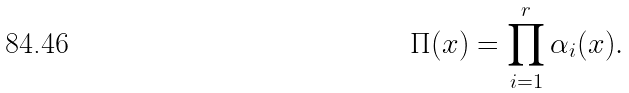<formula> <loc_0><loc_0><loc_500><loc_500>\Pi ( x ) = \prod _ { i = 1 } ^ { r } \alpha _ { i } ( x ) .</formula> 